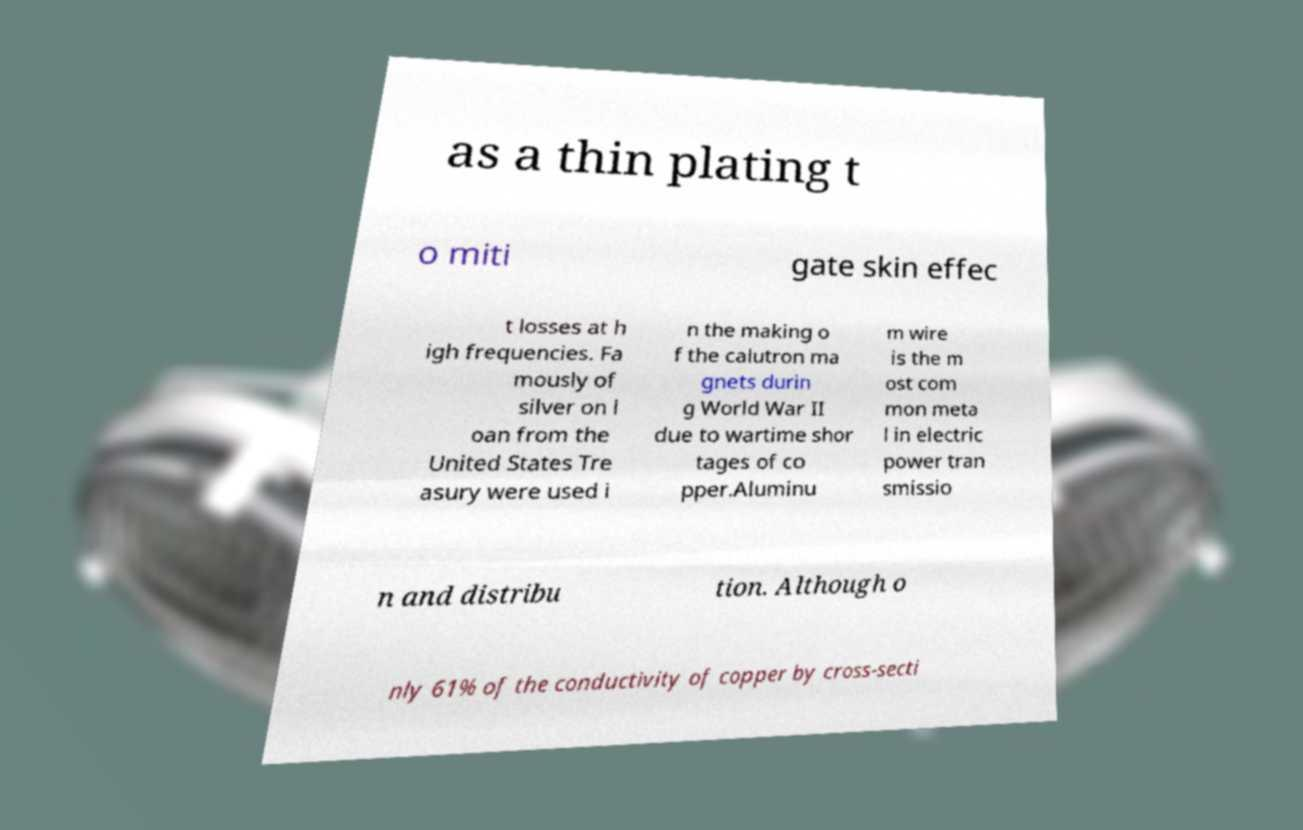Please read and relay the text visible in this image. What does it say? as a thin plating t o miti gate skin effec t losses at h igh frequencies. Fa mously of silver on l oan from the United States Tre asury were used i n the making o f the calutron ma gnets durin g World War II due to wartime shor tages of co pper.Aluminu m wire is the m ost com mon meta l in electric power tran smissio n and distribu tion. Although o nly 61% of the conductivity of copper by cross-secti 